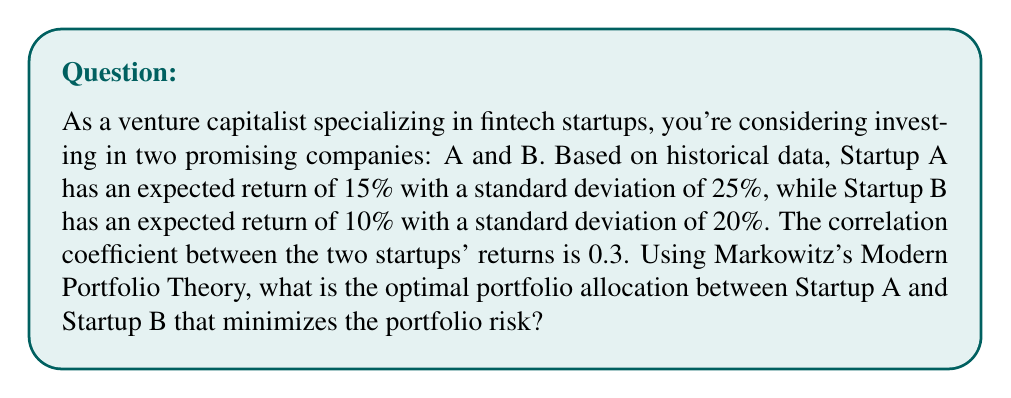Help me with this question. To solve this problem using Markowitz's Modern Portfolio Theory, we'll follow these steps:

1. Define variables:
   $r_A = 15\%$ (expected return of Startup A)
   $r_B = 10\%$ (expected return of Startup B)
   $\sigma_A = 25\%$ (standard deviation of Startup A)
   $\sigma_B = 20\%$ (standard deviation of Startup B)
   $\rho_{AB} = 0.3$ (correlation coefficient between A and B)
   $w_A$ (weight of Startup A in the portfolio)
   $w_B = 1 - w_A$ (weight of Startup B in the portfolio)

2. The portfolio variance formula is:
   $$\sigma_p^2 = w_A^2\sigma_A^2 + w_B^2\sigma_B^2 + 2w_Aw_B\sigma_A\sigma_B\rho_{AB}$$

3. To minimize risk, we need to find the weight $w_A$ that minimizes $\sigma_p^2$. We can do this by taking the derivative of $\sigma_p^2$ with respect to $w_A$ and setting it to zero:

   $$\frac{d\sigma_p^2}{dw_A} = 2w_A\sigma_A^2 + 2(w_A-1)\sigma_B^2 + 2(1-2w_A)\sigma_A\sigma_B\rho_{AB} = 0$$

4. Solve the equation:
   $$w_A\sigma_A^2 + (w_A-1)\sigma_B^2 + (1-2w_A)\sigma_A\sigma_B\rho_{AB} = 0$$
   $$w_A(\sigma_A^2 + \sigma_B^2 - 2\sigma_A\sigma_B\rho_{AB}) = \sigma_B^2 - \sigma_A\sigma_B\rho_{AB}$$

   $$w_A = \frac{\sigma_B^2 - \sigma_A\sigma_B\rho_{AB}}{\sigma_A^2 + \sigma_B^2 - 2\sigma_A\sigma_B\rho_{AB}}$$

5. Substitute the given values:
   $$w_A = \frac{0.20^2 - 0.25 \cdot 0.20 \cdot 0.3}{0.25^2 + 0.20^2 - 2 \cdot 0.25 \cdot 0.20 \cdot 0.3}$$
   $$w_A = \frac{0.04 - 0.015}{0.0625 + 0.04 - 0.03} = \frac{0.025}{0.0725} \approx 0.3448$$

6. Calculate $w_B$:
   $$w_B = 1 - w_A \approx 1 - 0.3448 = 0.6552$$

Therefore, the optimal portfolio allocation that minimizes risk is approximately 34.48% in Startup A and 65.52% in Startup B.
Answer: 34.48% in Startup A, 65.52% in Startup B 